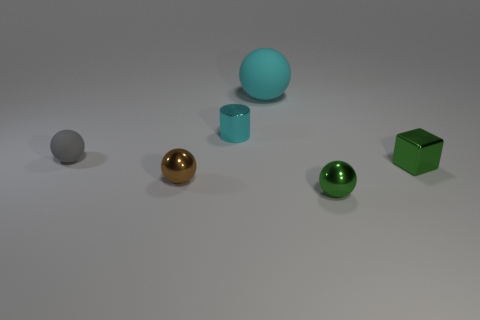Subtract all tiny brown spheres. How many spheres are left? 3 Subtract all green spheres. How many spheres are left? 3 Subtract all purple spheres. Subtract all red cubes. How many spheres are left? 4 Add 3 small gray shiny cylinders. How many objects exist? 9 Subtract all cubes. How many objects are left? 5 Add 6 yellow objects. How many yellow objects exist? 6 Subtract 0 blue cubes. How many objects are left? 6 Subtract all metal cylinders. Subtract all cyan things. How many objects are left? 3 Add 2 tiny shiny objects. How many tiny shiny objects are left? 6 